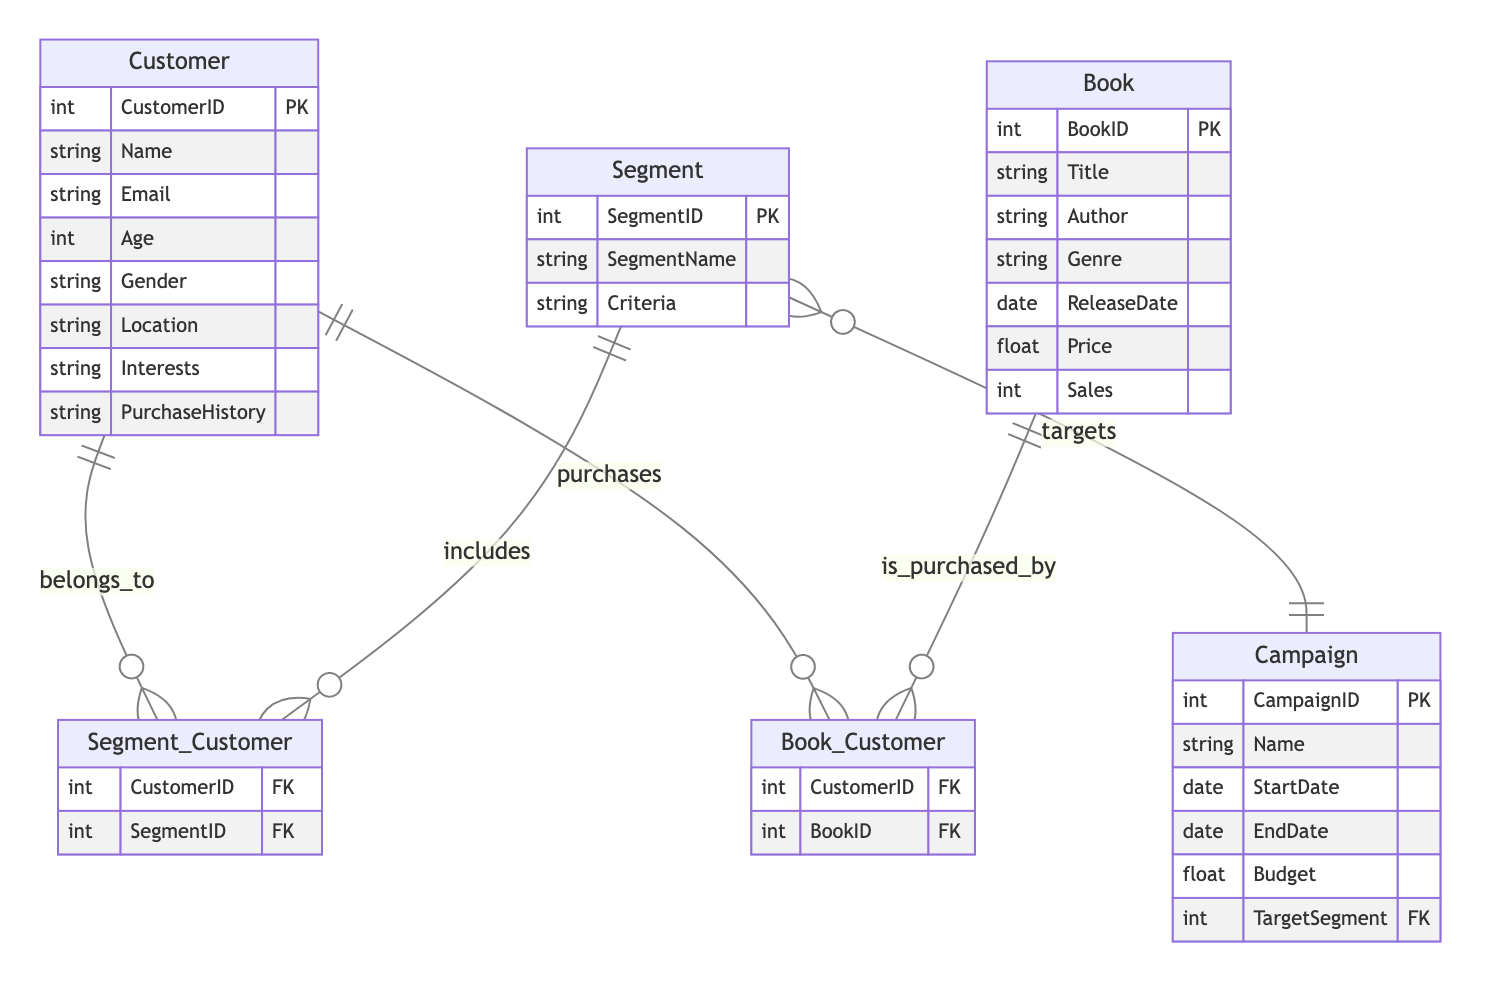What is the primary key of the Customer entity? The primary key of the Customer entity is CustomerID, which uniquely identifies each customer in the database.
Answer: CustomerID How many attributes are there in the Book entity? The Book entity has seven attributes: BookID, Title, Author, Genre, ReleaseDate, Price, and Sales.
Answer: Seven What is the relationship type between Campaign and Segment? The relationship type between Campaign and Segment is One-to-Many, meaning one campaign can target multiple segments, but each segment is only related to a single campaign at a time.
Answer: One-to-Many What does the Segment_Customer relationship signify? The Segment_Customer relationship signifies that a customer can belong to multiple segments, and each segment can include multiple customers, indicating a Many-to-Many relationship.
Answer: Many-to-Many Which entity contains the attribute named Price? The attribute named Price is contained within the Book entity, which represents the pricing information of each book.
Answer: Book If a Campaign targets 3 segments, how many distinct segments can be associated with it? A Campaign targeting 3 segments can have as many as 3 distinct segments associated with it, as each campaign can relate to multiple segments.
Answer: Three What information does the attribute PurchaseHistory in the Customer entity contain? The PurchaseHistory attribute contains information about the purchases made by a customer, reflecting their buying behavior and interests in books.
Answer: Purchases made by a customer How are customers linked to books in the diagram? Customers are linked to books through the Book_Customer relationship, indicating a Many-to-Many relationship where customers can purchase multiple books, and books can be purchased by multiple customers.
Answer: Through the Book_Customer relationship What attribute in the Campaign entity specifies the budget for marketing? The attribute that specifies the budget for marketing in the Campaign entity is Budget, which determines the financial resources allocated to each campaign.
Answer: Budget 